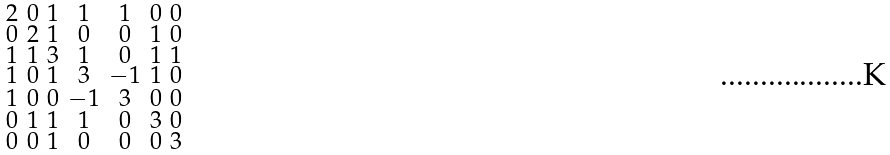<formula> <loc_0><loc_0><loc_500><loc_500>\begin{smallmatrix} 2 & 0 & 1 & 1 & 1 & 0 & 0 \\ 0 & 2 & 1 & 0 & 0 & 1 & 0 \\ 1 & 1 & 3 & 1 & 0 & 1 & 1 \\ 1 & 0 & 1 & 3 & - 1 & 1 & 0 \\ 1 & 0 & 0 & - 1 & 3 & 0 & 0 \\ 0 & 1 & 1 & 1 & 0 & 3 & 0 \\ 0 & 0 & 1 & 0 & 0 & 0 & 3 \end{smallmatrix}</formula> 